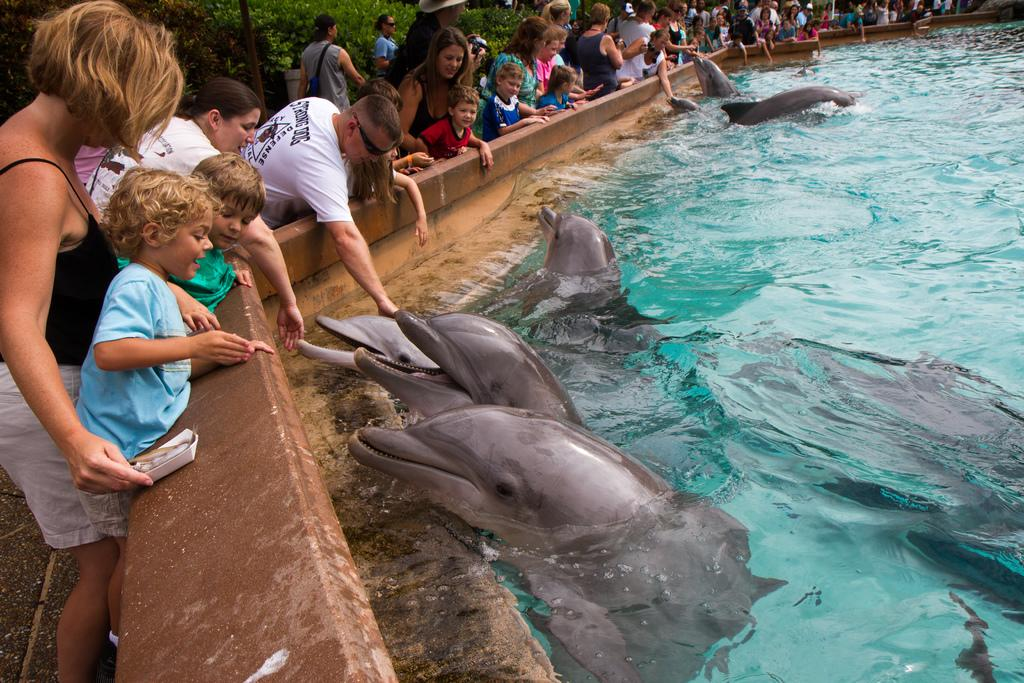What animals can be seen in the water in the image? There are dolphins in the water in the image. What are the people near the wall in the image doing? The people standing near a wall in the image are not engaged in any specific activity. What can be seen in the background of the image? In the background, there are people walking on the road and trees are visible. What type of cake is being served to the dolphins in the image? There is no cake present in the image; it features dolphins in the water and people near a wall. 